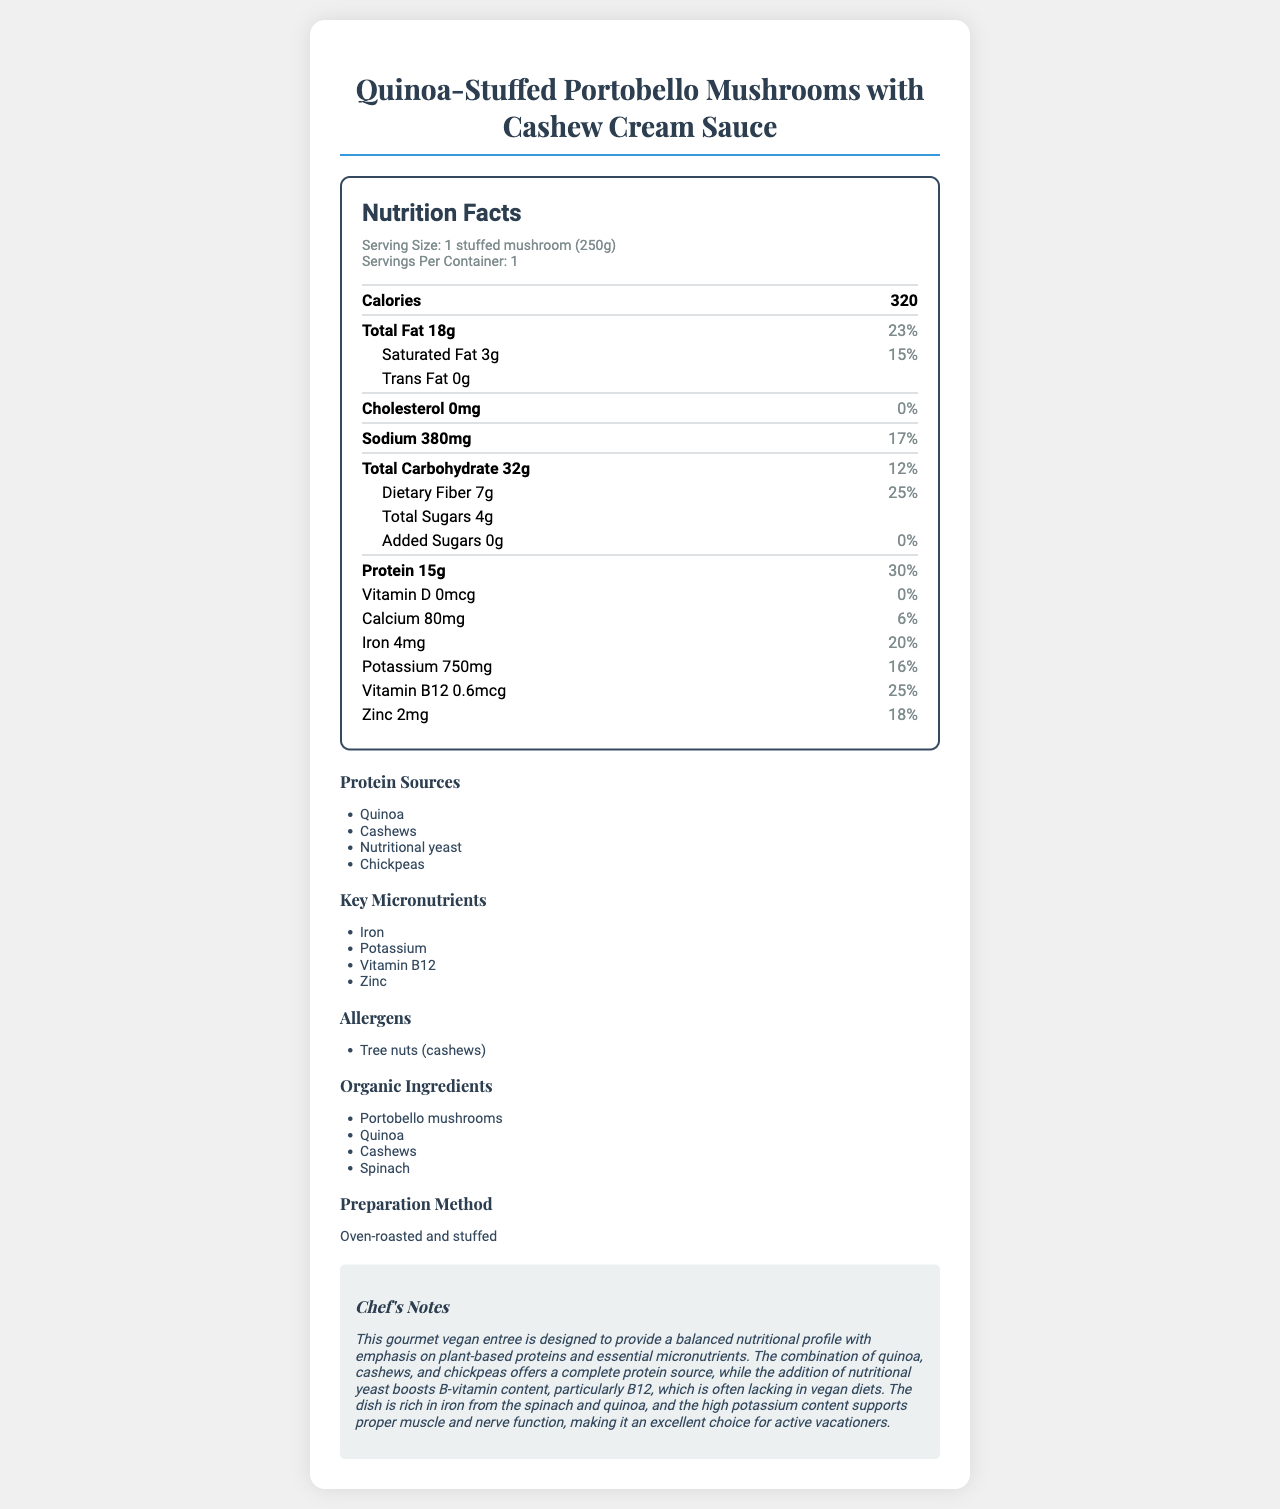what is the serving size for the vegan entree? The serving size is specified under the "Serving Size" section of the document.
Answer: 1 stuffed mushroom (250g) how many calories does one serving contain? The number of calories per serving is listed under the "Calories" section.
Answer: 320 list the protein sources included in this dish. The "Protein Sources" section lists these ingredients.
Answer: Quinoa, Cashews, Nutritional yeast, Chickpeas how much protein is in one serving of the vegan entree? The protein content is listed under the "Protein" section of the Nutrition Facts.
Answer: 15g which micronutrient has the highest daily value percentage in this dish? The Iron content has a daily value percentage of 20%, which is the highest among the listed micronutrients.
Answer: Iron what is the daily value percentage of saturated fat in this dish? A. 10% B. 15% C. 20% D. 25% The daily value percentage of saturated fat is 15%, as listed under the "Saturated Fat" section.
Answer: B. 15% which of the following nutrients is not present in this dish? I. Vitamin A II. Vitamin D III. Vitamin C Vitamins A and C are not listed in the Nutrition Facts, while Vitamin D is mentioned with 0mcg content.
Answer: I, III are there any trans fats in the vegan entree? The trans fat content is listed as 0g in the Nutrition Facts.
Answer: No briefly summarize the key nutritional benefits of this vegan entree. The summary merges information from different sections, providing insights into protein content, micronutrients, organic ingredients, and dietary fiber.
Answer: The vegan entree provides a balanced nutritional profile with a good amount of plant-based protein (15g) and key micronutrients such as Iron (20% DV), Potassium (16% DV), Vitamin B12 (25% DV), and Zinc (18% DV). It also includes organic ingredients and emphasizes dietary fiber (25% DV). what is the proportion of saturated to total fat in the vegan entree? There are 3g of saturated fat out of a total of 18g of fat, resulting in a proportion of 3:18 or 1:6.
Answer: 1:6 does the dish contain any allergens? If so, what are they? The allergens section lists Tree nuts (cashews) as the allergen present.
Answer: Yes, Tree nuts (cashews) is the potassium content in this dish high, medium, or low compared to the daily value? The potassium content is 750mg, which amounts to 16% of the daily value. This is neither very high nor very low but moderate.
Answer: Medium how is the dish prepared? The preparation method is mentioned in the respective section of the document.
Answer: Oven-roasted and stuffed what types of ingredients are used in this dish? The dish includes organic ingredients like Portobello mushrooms, Quinoa, Cashews, and Spinach.
Answer: Organic ingredients what are the key micronutrients highlighted in this vegan entree? The "Key Micronutrients" section lists these nutrients.
Answer: Iron, Potassium, Vitamin B12, Zinc which vitamins are included in the nutritional data? The Nutrition Facts label mentions Vitamin D and Vitamin B12 specifically.
Answer: Vitamin D and Vitamin B12 explain the chef's notes provided in the document. The chef's notes provide an overview of the nutritional philosophy behind the dish and its benefits, emphasizing proteins, B-vitamins, iron, and potassium.
Answer: The dish is designed to be nutritionally balanced, focusing on plant-based proteins and essential micronutrients. It includes complete protein sources through quinoa, cashews, and chickpeas, and boosts B-vitamin content with nutritional yeast. It's rich in iron and potassium, supporting muscle and nerve function, making it ideal for active vacationers. what is the total carbohydrate content in the dish? The total carbohydrate content is listed under the "Total Carbohydrate" section.
Answer: 32g does the dish contain any cholesterol? The cholesterol content is listed as 0mg in the Nutrition Facts.
Answer: No how many grams of dietary fiber are in one serving? The dietary fiber content is listed as 7g.
Answer: 7g can you determine the amount of sodium in milligrams without any additional calculations? The sodium content is directly listed in milligrams as 380mg in the Nutrition Facts.
Answer: Yes, it is 380mg what is the organic ingredient used in the dish? The document lists several organic ingredients but does not specify which ingredient specifically is being asked for.
Answer: Cannot be determined how much Vitamin B12 is in one serving? The Vitamin B12 content is listed as 0.6mcg under the Nutrition Facts.
Answer: 0.6mcg which protein source listed also contributes to Vitamin B12 in the dish? The chef's notes and nutritional information suggest that nutritional yeast is used to boost B-vitamin content, including Vitamin B12.
Answer: Nutritional yeast 